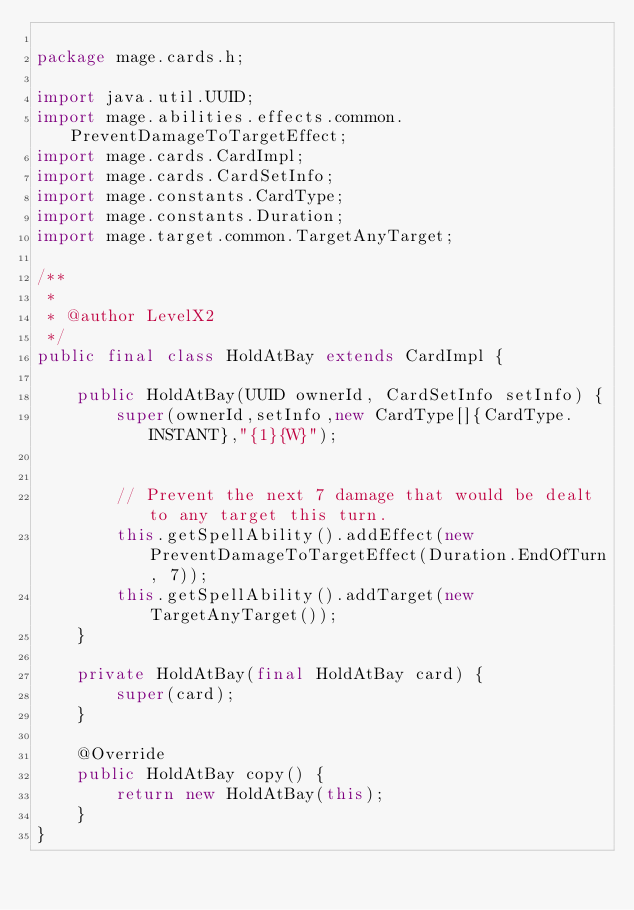<code> <loc_0><loc_0><loc_500><loc_500><_Java_>
package mage.cards.h;

import java.util.UUID;
import mage.abilities.effects.common.PreventDamageToTargetEffect;
import mage.cards.CardImpl;
import mage.cards.CardSetInfo;
import mage.constants.CardType;
import mage.constants.Duration;
import mage.target.common.TargetAnyTarget;

/**
 *
 * @author LevelX2
 */
public final class HoldAtBay extends CardImpl {

    public HoldAtBay(UUID ownerId, CardSetInfo setInfo) {
        super(ownerId,setInfo,new CardType[]{CardType.INSTANT},"{1}{W}");


        // Prevent the next 7 damage that would be dealt to any target this turn.
        this.getSpellAbility().addEffect(new PreventDamageToTargetEffect(Duration.EndOfTurn, 7));
        this.getSpellAbility().addTarget(new TargetAnyTarget());
    }

    private HoldAtBay(final HoldAtBay card) {
        super(card);
    }

    @Override
    public HoldAtBay copy() {
        return new HoldAtBay(this);
    }
}
</code> 